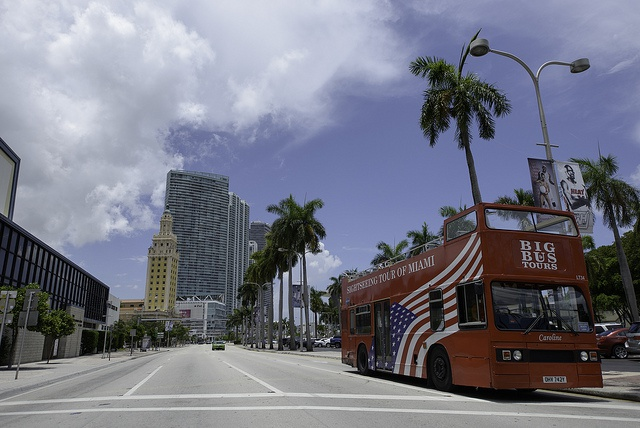Describe the objects in this image and their specific colors. I can see bus in lightgray, black, maroon, and gray tones, car in lightgray, black, maroon, and gray tones, car in lightgray, black, and gray tones, car in lightgray, black, gray, and darkgray tones, and people in black and lightgray tones in this image. 